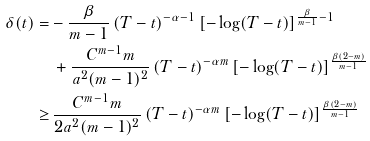Convert formula to latex. <formula><loc_0><loc_0><loc_500><loc_500>\delta ( t ) = & - \frac { \beta } { m - 1 } \, ( T - t ) ^ { - \alpha - 1 } \, [ - \log ( T - t ) ] ^ { \frac { \beta } { m - 1 } - 1 } \\ & \, + \frac { C ^ { m - 1 } m } { a ^ { 2 } ( m - 1 ) ^ { 2 } } \, ( T - t ) ^ { - \alpha m } \, [ - \log ( T - t ) ] ^ { \frac { \beta ( 2 - m ) } { m - 1 } } \\ \geq & \, \frac { C ^ { m - 1 } m } { 2 a ^ { 2 } ( m - 1 ) ^ { 2 } } \, ( T - t ) ^ { - \alpha m } \, [ - \log ( T - t ) ] ^ { \frac { \beta ( 2 - m ) } { m - 1 } }</formula> 